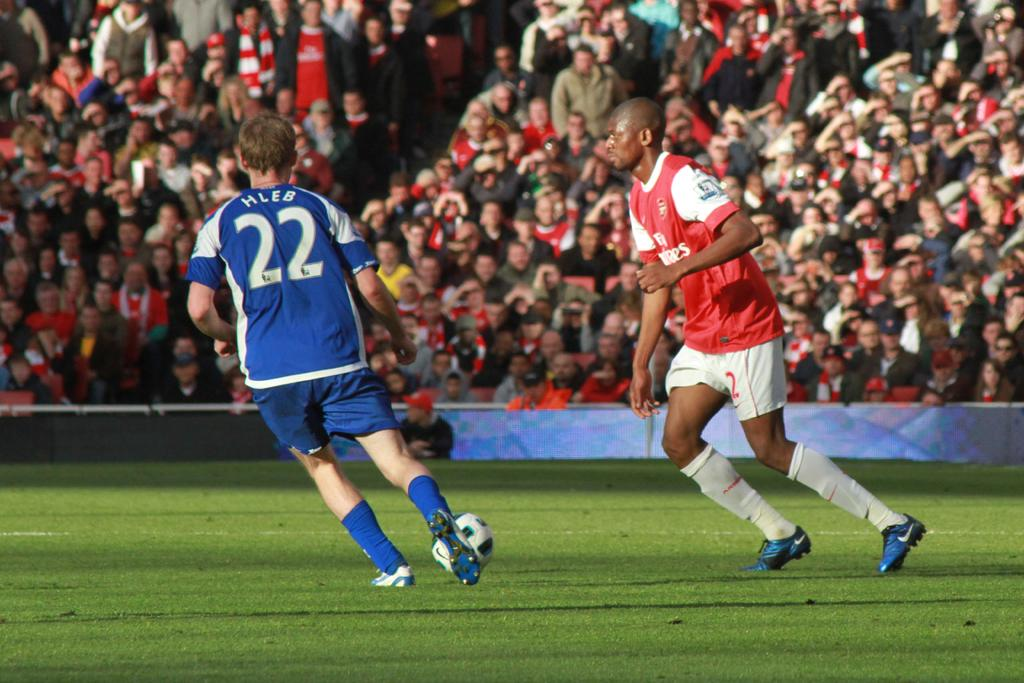<image>
Offer a succinct explanation of the picture presented. Two players are on a field and one wears a jersey with the number 22 on it. 